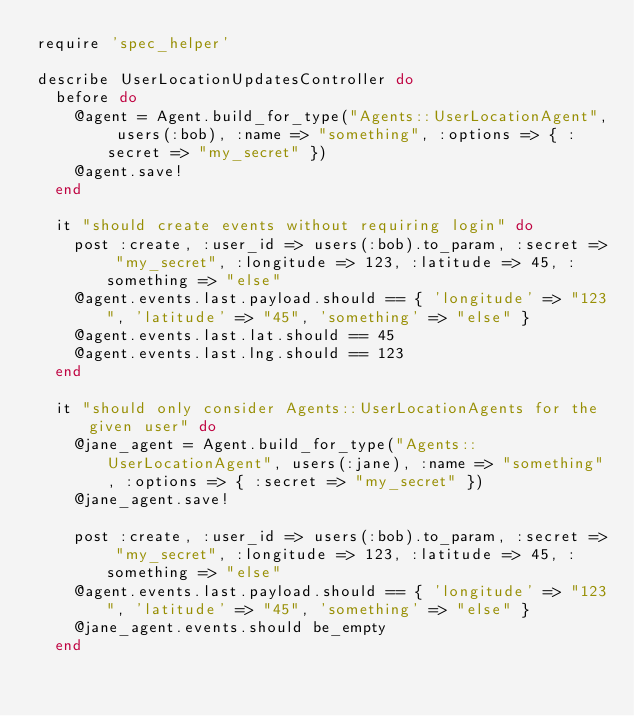<code> <loc_0><loc_0><loc_500><loc_500><_Ruby_>require 'spec_helper'

describe UserLocationUpdatesController do
  before do
    @agent = Agent.build_for_type("Agents::UserLocationAgent", users(:bob), :name => "something", :options => { :secret => "my_secret" })
    @agent.save!
  end

  it "should create events without requiring login" do
    post :create, :user_id => users(:bob).to_param, :secret => "my_secret", :longitude => 123, :latitude => 45, :something => "else"
    @agent.events.last.payload.should == { 'longitude' => "123", 'latitude' => "45", 'something' => "else" }
    @agent.events.last.lat.should == 45
    @agent.events.last.lng.should == 123
  end

  it "should only consider Agents::UserLocationAgents for the given user" do
    @jane_agent = Agent.build_for_type("Agents::UserLocationAgent", users(:jane), :name => "something", :options => { :secret => "my_secret" })
    @jane_agent.save!

    post :create, :user_id => users(:bob).to_param, :secret => "my_secret", :longitude => 123, :latitude => 45, :something => "else"
    @agent.events.last.payload.should == { 'longitude' => "123", 'latitude' => "45", 'something' => "else" }
    @jane_agent.events.should be_empty
  end
</code> 